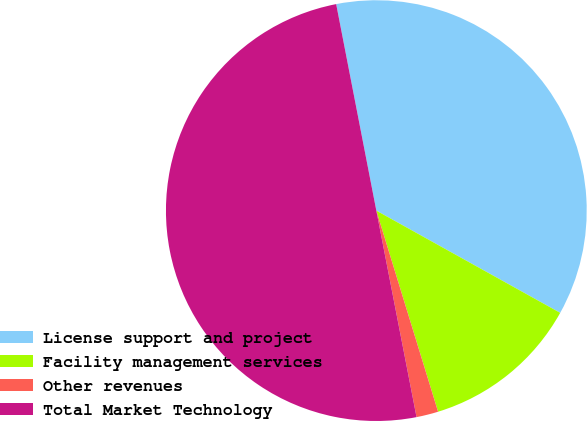<chart> <loc_0><loc_0><loc_500><loc_500><pie_chart><fcel>License support and project<fcel>Facility management services<fcel>Other revenues<fcel>Total Market Technology<nl><fcel>36.13%<fcel>12.18%<fcel>1.68%<fcel>50.0%<nl></chart> 